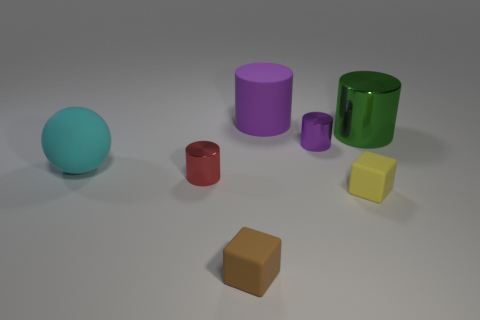There is a object that is the same color as the rubber cylinder; what is its material?
Make the answer very short. Metal. Are there fewer large things than brown matte objects?
Your response must be concise. No. There is a tiny thing that is left of the brown rubber block; what is its material?
Ensure brevity in your answer.  Metal. There is a brown thing that is the same size as the yellow block; what material is it?
Give a very brief answer. Rubber. What is the material of the big thing that is in front of the small shiny thing that is on the right side of the cylinder in front of the small purple metal object?
Your answer should be compact. Rubber. Do the cylinder in front of the rubber ball and the purple metal thing have the same size?
Make the answer very short. Yes. Is the number of small yellow shiny cubes greater than the number of rubber spheres?
Offer a terse response. No. What number of big objects are either yellow rubber blocks or blue rubber cubes?
Offer a very short reply. 0. What number of other things are the same color as the rubber cylinder?
Make the answer very short. 1. How many tiny yellow cubes have the same material as the small brown thing?
Keep it short and to the point. 1. 